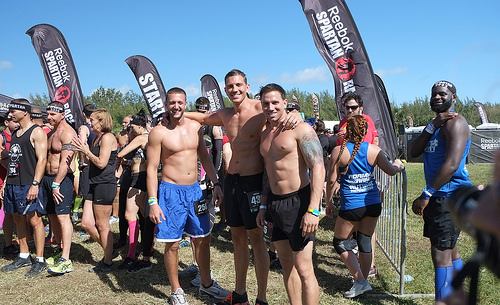<image>
Can you confirm if the man is to the left of the man? Yes. From this viewpoint, the man is positioned to the left side relative to the man. 